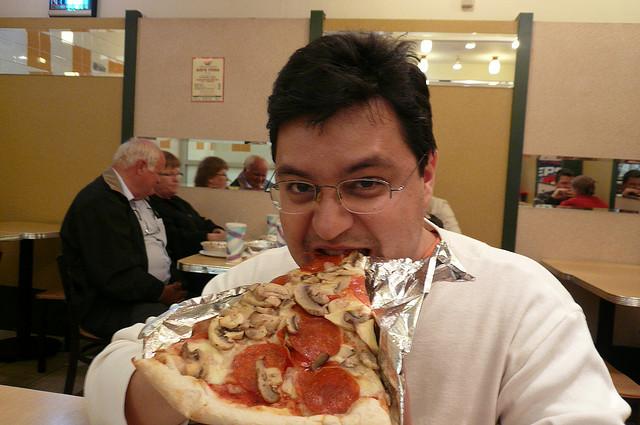What is the vegetable on this pizza?
Concise answer only. Mushroom. Is this a garlic breadstick?
Give a very brief answer. No. Is the foil going to keep grease off his face?
Write a very short answer. No. What topping is on the man's pizza?
Give a very brief answer. Pepperoni and mushroom. What is the man eating?
Answer briefly. Pizza. What is he eating?
Write a very short answer. Pizza. Is the gray haired man in the background possibly overweight?
Concise answer only. Yes. 